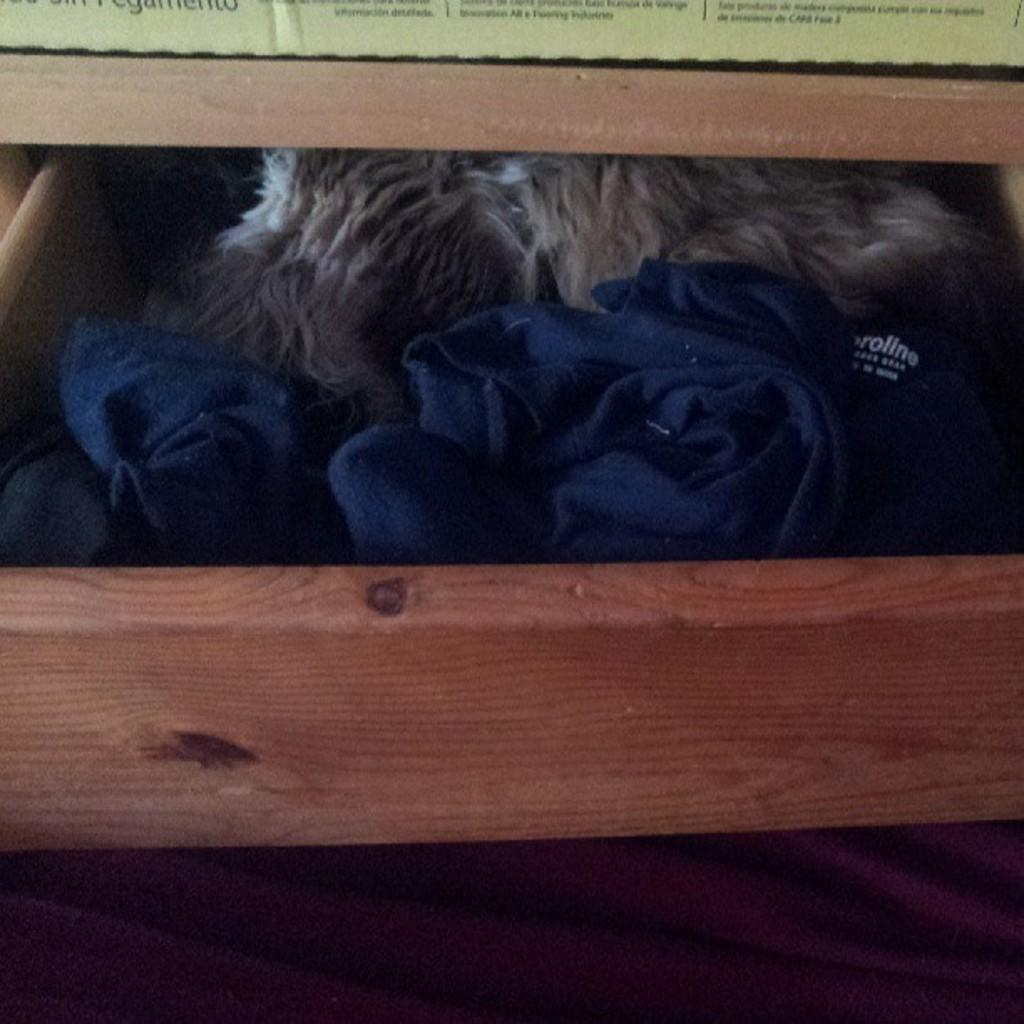What is located inside the drawer in the image? There are clothes in the drawer. What is the purpose of the drawer in the image? The drawer is likely used for storing clothes. What can be seen at the top of the image? There is text at the top of the image. How many cubs are visible in the image? There are no cubs present in the image. What type of cup is being used to hold the cherries in the image? There are no cups or cherries present in the image. 